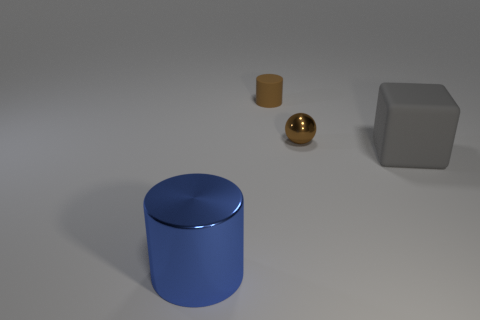Subtract all blue cylinders. How many cylinders are left? 1 Add 2 small blue shiny blocks. How many objects exist? 6 Subtract 1 brown cylinders. How many objects are left? 3 Subtract all spheres. How many objects are left? 3 Subtract all purple blocks. Subtract all gray cylinders. How many blocks are left? 1 Subtract all gray cubes. How many red cylinders are left? 0 Subtract all tiny red objects. Subtract all small things. How many objects are left? 2 Add 3 large blue cylinders. How many large blue cylinders are left? 4 Add 4 small rubber cylinders. How many small rubber cylinders exist? 5 